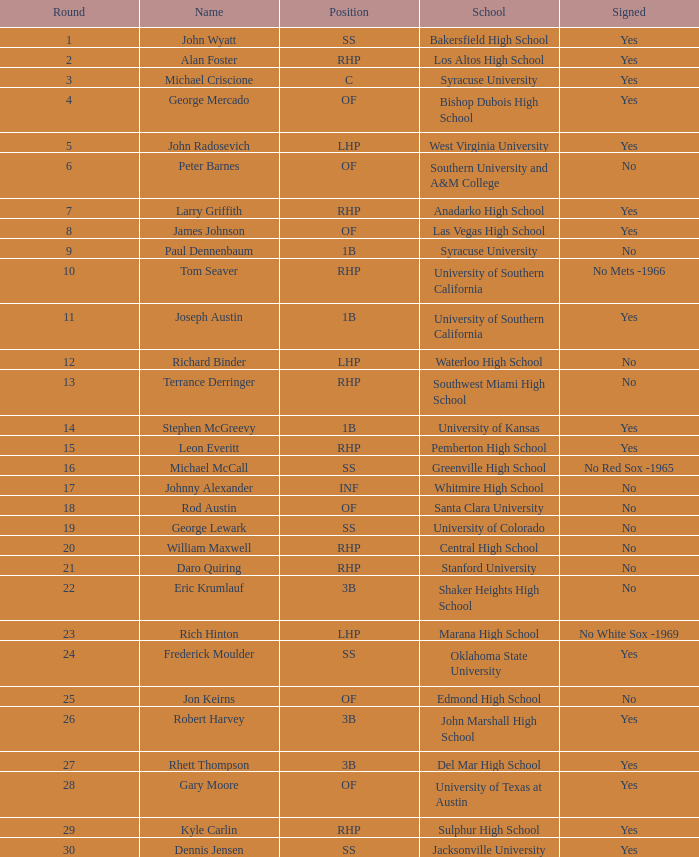What is the name of the athlete selected in round 23? Rich Hinton. 